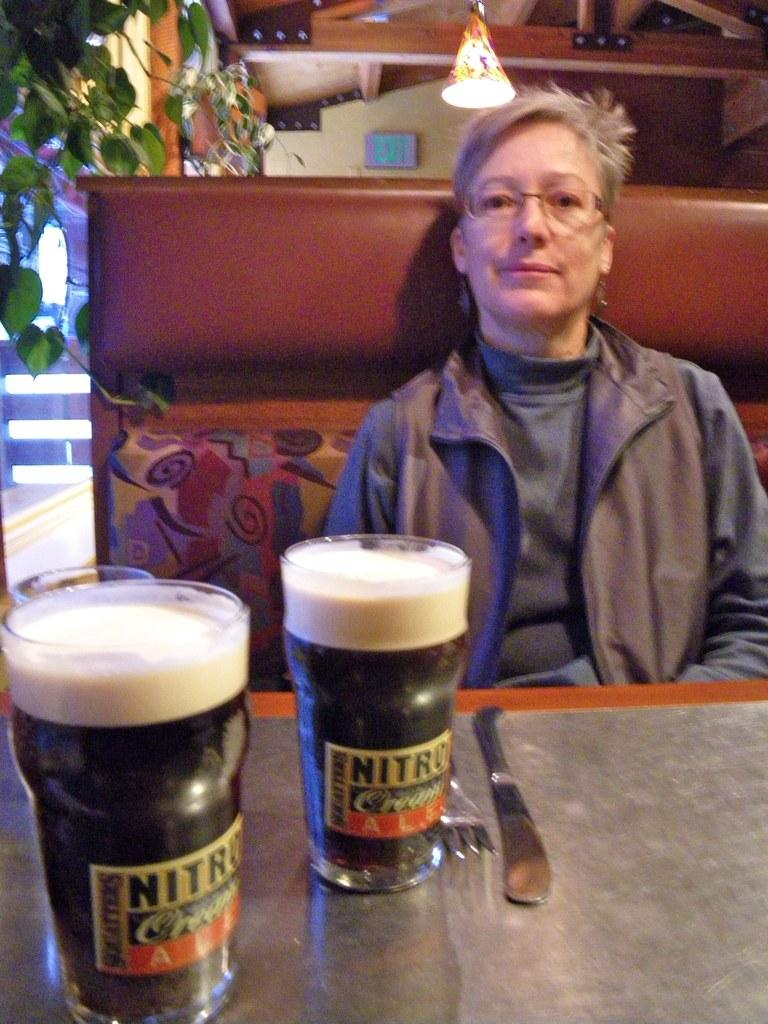<image>
Relay a brief, clear account of the picture shown. A person sitting in front of two points of dark beer with the words nitro on the glasses. 